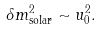Convert formula to latex. <formula><loc_0><loc_0><loc_500><loc_500>\delta m ^ { 2 } _ { \text {solar} } \sim u _ { 0 } ^ { 2 } .</formula> 